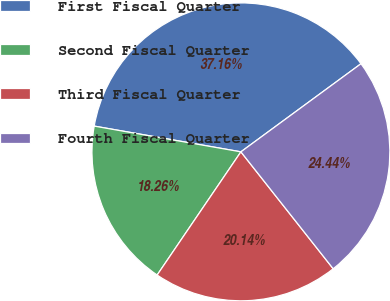Convert chart. <chart><loc_0><loc_0><loc_500><loc_500><pie_chart><fcel>First Fiscal Quarter<fcel>Second Fiscal Quarter<fcel>Third Fiscal Quarter<fcel>Fourth Fiscal Quarter<nl><fcel>37.16%<fcel>18.26%<fcel>20.14%<fcel>24.44%<nl></chart> 